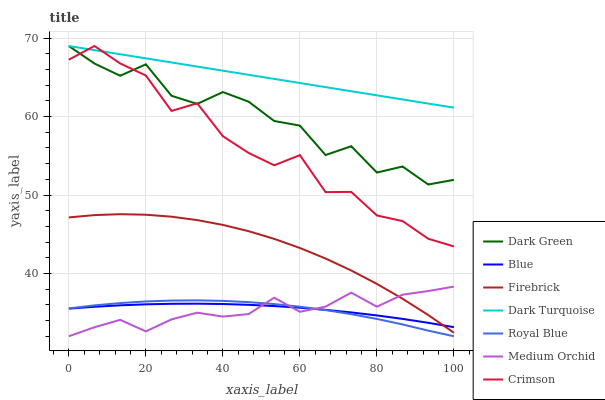Does Medium Orchid have the minimum area under the curve?
Answer yes or no. Yes. Does Dark Turquoise have the maximum area under the curve?
Answer yes or no. Yes. Does Firebrick have the minimum area under the curve?
Answer yes or no. No. Does Firebrick have the maximum area under the curve?
Answer yes or no. No. Is Dark Turquoise the smoothest?
Answer yes or no. Yes. Is Dark Green the roughest?
Answer yes or no. Yes. Is Firebrick the smoothest?
Answer yes or no. No. Is Firebrick the roughest?
Answer yes or no. No. Does Firebrick have the lowest value?
Answer yes or no. No. Does Dark Green have the highest value?
Answer yes or no. Yes. Does Firebrick have the highest value?
Answer yes or no. No. Is Firebrick less than Crimson?
Answer yes or no. Yes. Is Crimson greater than Firebrick?
Answer yes or no. Yes. Does Dark Green intersect Crimson?
Answer yes or no. Yes. Is Dark Green less than Crimson?
Answer yes or no. No. Is Dark Green greater than Crimson?
Answer yes or no. No. Does Firebrick intersect Crimson?
Answer yes or no. No. 